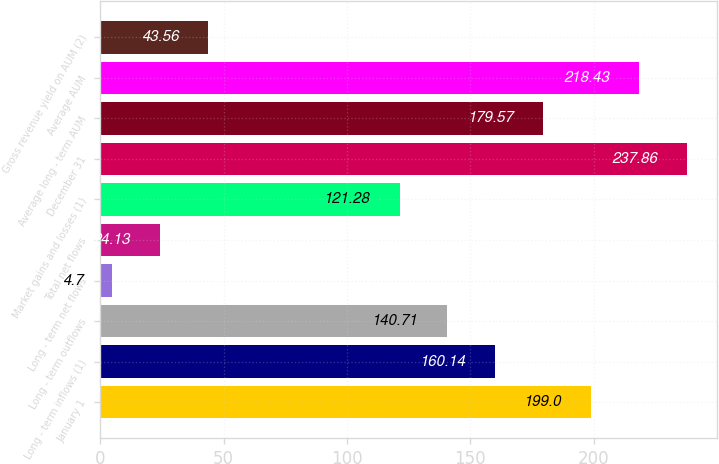Convert chart to OTSL. <chart><loc_0><loc_0><loc_500><loc_500><bar_chart><fcel>January 1<fcel>Long - term inflows (1)<fcel>Long - term outflows<fcel>Long - term net flows<fcel>Total net flows<fcel>Market gains and losses (1)<fcel>December 31<fcel>Average long - term AUM<fcel>Average AUM<fcel>Gross revenue yield on AUM (2)<nl><fcel>199<fcel>160.14<fcel>140.71<fcel>4.7<fcel>24.13<fcel>121.28<fcel>237.86<fcel>179.57<fcel>218.43<fcel>43.56<nl></chart> 